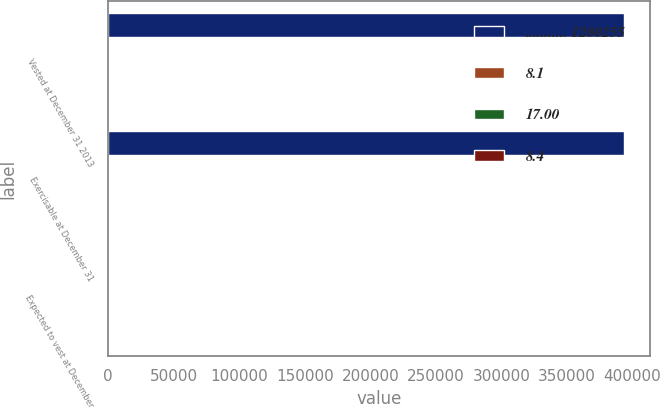Convert chart. <chart><loc_0><loc_0><loc_500><loc_500><stacked_bar_chart><ecel><fcel>Vested at December 31 2013<fcel>Exercisable at December 31<fcel>Expected to vest at December<nl><fcel>........... 1280255<fcel>393517<fcel>393517<fcel>8.6<nl><fcel>8.1<fcel>17<fcel>17<fcel>17<nl><fcel>17.00<fcel>8<fcel>8<fcel>8.6<nl><fcel>8.4<fcel>2.5<fcel>2.5<fcel>5.4<nl></chart> 